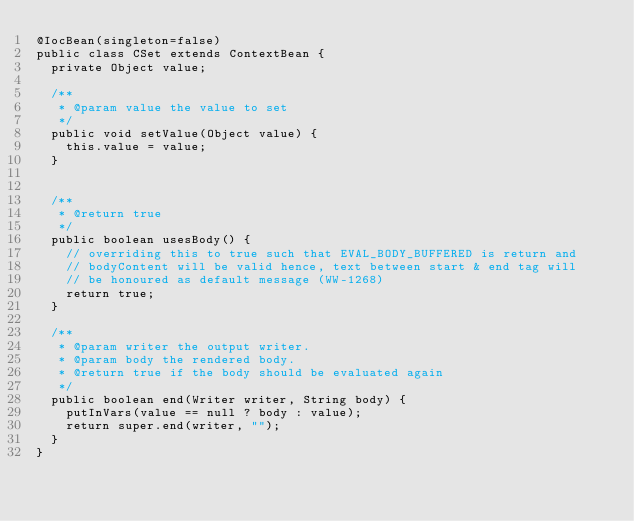<code> <loc_0><loc_0><loc_500><loc_500><_Java_>@IocBean(singleton=false)
public class CSet extends ContextBean {
	private Object value;

	/**
	 * @param value the value to set
	 */
	public void setValue(Object value) {
		this.value = value;
	}


	/**
	 * @return true
	 */
	public boolean usesBody() {
		// overriding this to true such that EVAL_BODY_BUFFERED is return and
		// bodyContent will be valid hence, text between start & end tag will
		// be honoured as default message (WW-1268)
		return true;
	}

	/**
	 * @param writer the output writer.
	 * @param body the rendered body.
	 * @return true if the body should be evaluated again
	 */
	public boolean end(Writer writer, String body) {
		putInVars(value == null ? body : value);
		return super.end(writer, "");
	}
}
</code> 